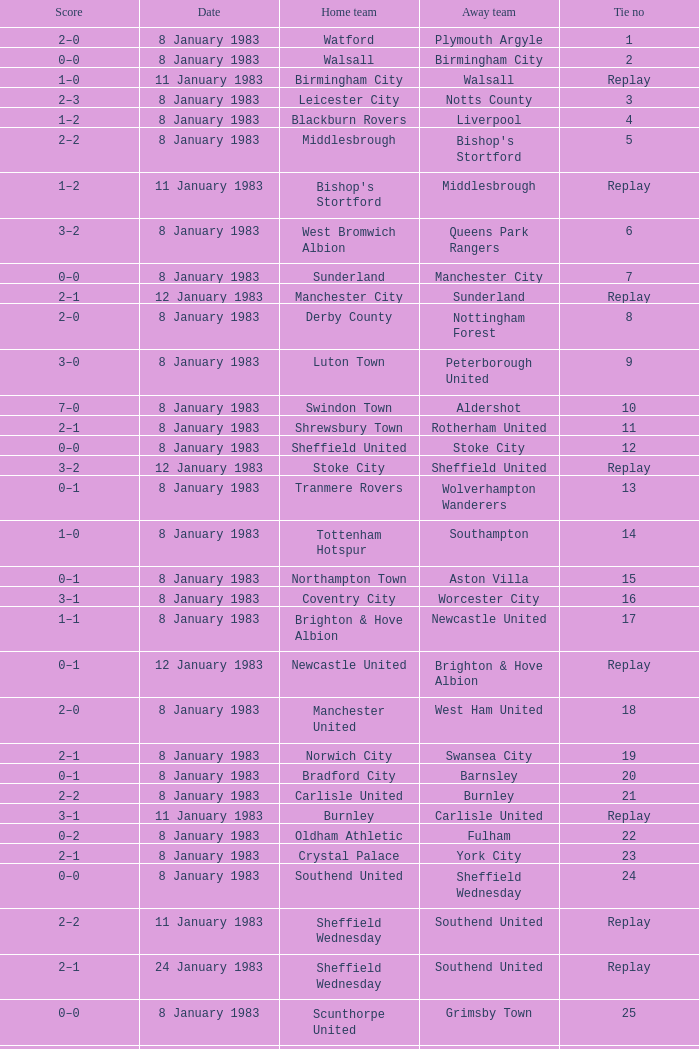What was the final score for the tie where Leeds United was the home team? 3–0. I'm looking to parse the entire table for insights. Could you assist me with that? {'header': ['Score', 'Date', 'Home team', 'Away team', 'Tie no'], 'rows': [['2–0', '8 January 1983', 'Watford', 'Plymouth Argyle', '1'], ['0–0', '8 January 1983', 'Walsall', 'Birmingham City', '2'], ['1–0', '11 January 1983', 'Birmingham City', 'Walsall', 'Replay'], ['2–3', '8 January 1983', 'Leicester City', 'Notts County', '3'], ['1–2', '8 January 1983', 'Blackburn Rovers', 'Liverpool', '4'], ['2–2', '8 January 1983', 'Middlesbrough', "Bishop's Stortford", '5'], ['1–2', '11 January 1983', "Bishop's Stortford", 'Middlesbrough', 'Replay'], ['3–2', '8 January 1983', 'West Bromwich Albion', 'Queens Park Rangers', '6'], ['0–0', '8 January 1983', 'Sunderland', 'Manchester City', '7'], ['2–1', '12 January 1983', 'Manchester City', 'Sunderland', 'Replay'], ['2–0', '8 January 1983', 'Derby County', 'Nottingham Forest', '8'], ['3–0', '8 January 1983', 'Luton Town', 'Peterborough United', '9'], ['7–0', '8 January 1983', 'Swindon Town', 'Aldershot', '10'], ['2–1', '8 January 1983', 'Shrewsbury Town', 'Rotherham United', '11'], ['0–0', '8 January 1983', 'Sheffield United', 'Stoke City', '12'], ['3–2', '12 January 1983', 'Stoke City', 'Sheffield United', 'Replay'], ['0–1', '8 January 1983', 'Tranmere Rovers', 'Wolverhampton Wanderers', '13'], ['1–0', '8 January 1983', 'Tottenham Hotspur', 'Southampton', '14'], ['0–1', '8 January 1983', 'Northampton Town', 'Aston Villa', '15'], ['3–1', '8 January 1983', 'Coventry City', 'Worcester City', '16'], ['1–1', '8 January 1983', 'Brighton & Hove Albion', 'Newcastle United', '17'], ['0–1', '12 January 1983', 'Newcastle United', 'Brighton & Hove Albion', 'Replay'], ['2–0', '8 January 1983', 'Manchester United', 'West Ham United', '18'], ['2–1', '8 January 1983', 'Norwich City', 'Swansea City', '19'], ['0–1', '8 January 1983', 'Bradford City', 'Barnsley', '20'], ['2–2', '8 January 1983', 'Carlisle United', 'Burnley', '21'], ['3–1', '11 January 1983', 'Burnley', 'Carlisle United', 'Replay'], ['0–2', '8 January 1983', 'Oldham Athletic', 'Fulham', '22'], ['2–1', '8 January 1983', 'Crystal Palace', 'York City', '23'], ['0–0', '8 January 1983', 'Southend United', 'Sheffield Wednesday', '24'], ['2–2', '11 January 1983', 'Sheffield Wednesday', 'Southend United', 'Replay'], ['2–1', '24 January 1983', 'Sheffield Wednesday', 'Southend United', 'Replay'], ['0–0', '8 January 1983', 'Scunthorpe United', 'Grimsby Town', '25'], ['2–0', '11 January 1983', 'Grimsby Town', 'Scunthorpe United', 'Replay'], ['1–1', '8 January 1983', 'Huddersfield Town', 'Chelsea', '26'], ['2–0', '12 January 1983', 'Chelsea', 'Huddersfield Town', 'Replay'], ['1–1', '8 January 1983', 'Newport County', 'Everton', '27'], ['2–1', '11 January 1983', 'Everton', 'Newport County', 'Replay'], ['2–3', '8 January 1983', 'Charlton Athletic', 'Ipswich Town', '28'], ['2–1', '8 January 1983', 'Arsenal', 'Bolton Wanderers', '29'], ['3–0', '8 January 1983', 'Leeds United', 'Preston North End', '30'], ['1–0', '8 January 1983', 'Cambridge United', 'Weymouth', '31'], ['1–1', '8 January 1983', 'Oxford United', 'Torquay United', '32'], ['2–1', '12 January 1983', 'Torquay United', 'Oxford United', 'Replay']]} 